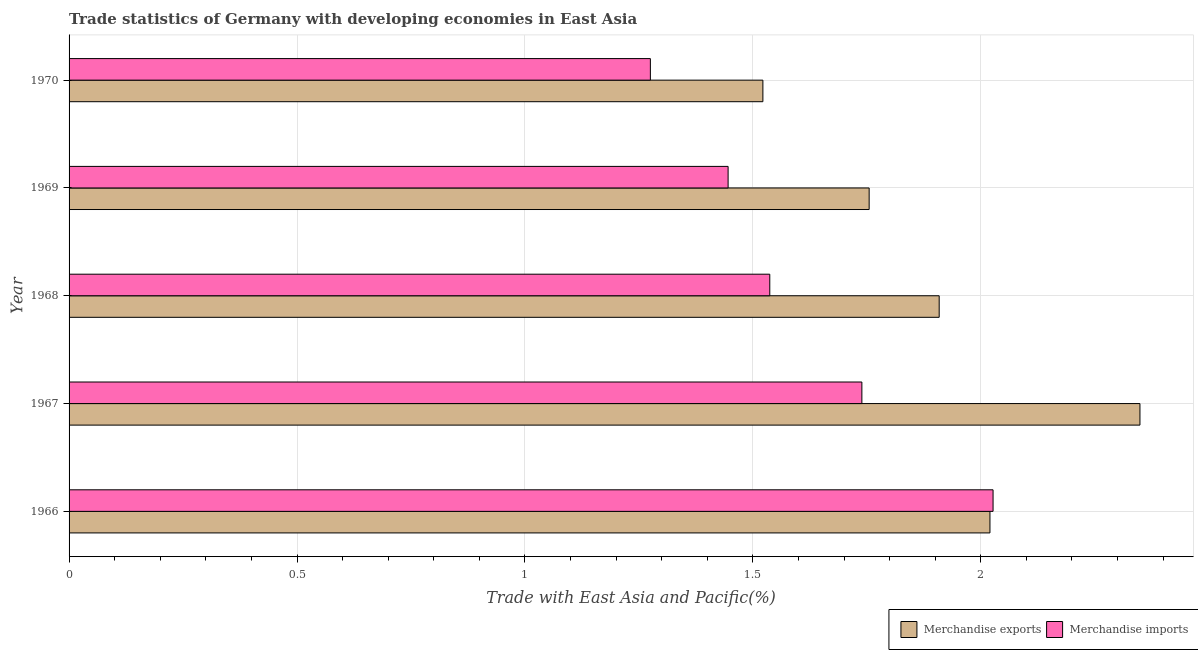How many groups of bars are there?
Make the answer very short. 5. Are the number of bars per tick equal to the number of legend labels?
Provide a succinct answer. Yes. How many bars are there on the 1st tick from the top?
Provide a short and direct response. 2. How many bars are there on the 5th tick from the bottom?
Ensure brevity in your answer.  2. What is the label of the 2nd group of bars from the top?
Keep it short and to the point. 1969. What is the merchandise exports in 1970?
Make the answer very short. 1.52. Across all years, what is the maximum merchandise imports?
Give a very brief answer. 2.03. Across all years, what is the minimum merchandise exports?
Make the answer very short. 1.52. In which year was the merchandise exports maximum?
Your answer should be very brief. 1967. What is the total merchandise exports in the graph?
Provide a short and direct response. 9.56. What is the difference between the merchandise imports in 1966 and that in 1969?
Make the answer very short. 0.58. What is the difference between the merchandise imports in 1967 and the merchandise exports in 1970?
Provide a short and direct response. 0.22. What is the average merchandise imports per year?
Keep it short and to the point. 1.6. In the year 1970, what is the difference between the merchandise imports and merchandise exports?
Keep it short and to the point. -0.25. In how many years, is the merchandise imports greater than 1.5 %?
Give a very brief answer. 3. What is the ratio of the merchandise exports in 1969 to that in 1970?
Keep it short and to the point. 1.15. What is the difference between the highest and the second highest merchandise exports?
Keep it short and to the point. 0.33. Is the sum of the merchandise imports in 1966 and 1970 greater than the maximum merchandise exports across all years?
Offer a terse response. Yes. What does the 1st bar from the top in 1968 represents?
Your answer should be compact. Merchandise imports. Are all the bars in the graph horizontal?
Offer a terse response. Yes. What is the difference between two consecutive major ticks on the X-axis?
Offer a terse response. 0.5. Does the graph contain grids?
Your response must be concise. Yes. Where does the legend appear in the graph?
Provide a short and direct response. Bottom right. How many legend labels are there?
Your answer should be very brief. 2. How are the legend labels stacked?
Keep it short and to the point. Horizontal. What is the title of the graph?
Offer a terse response. Trade statistics of Germany with developing economies in East Asia. Does "Current education expenditure" appear as one of the legend labels in the graph?
Offer a very short reply. No. What is the label or title of the X-axis?
Make the answer very short. Trade with East Asia and Pacific(%). What is the label or title of the Y-axis?
Ensure brevity in your answer.  Year. What is the Trade with East Asia and Pacific(%) in Merchandise exports in 1966?
Offer a terse response. 2.02. What is the Trade with East Asia and Pacific(%) in Merchandise imports in 1966?
Make the answer very short. 2.03. What is the Trade with East Asia and Pacific(%) of Merchandise exports in 1967?
Make the answer very short. 2.35. What is the Trade with East Asia and Pacific(%) in Merchandise imports in 1967?
Your response must be concise. 1.74. What is the Trade with East Asia and Pacific(%) in Merchandise exports in 1968?
Ensure brevity in your answer.  1.91. What is the Trade with East Asia and Pacific(%) in Merchandise imports in 1968?
Offer a terse response. 1.54. What is the Trade with East Asia and Pacific(%) in Merchandise exports in 1969?
Give a very brief answer. 1.76. What is the Trade with East Asia and Pacific(%) in Merchandise imports in 1969?
Ensure brevity in your answer.  1.45. What is the Trade with East Asia and Pacific(%) in Merchandise exports in 1970?
Ensure brevity in your answer.  1.52. What is the Trade with East Asia and Pacific(%) of Merchandise imports in 1970?
Make the answer very short. 1.28. Across all years, what is the maximum Trade with East Asia and Pacific(%) in Merchandise exports?
Offer a very short reply. 2.35. Across all years, what is the maximum Trade with East Asia and Pacific(%) in Merchandise imports?
Your answer should be very brief. 2.03. Across all years, what is the minimum Trade with East Asia and Pacific(%) of Merchandise exports?
Provide a short and direct response. 1.52. Across all years, what is the minimum Trade with East Asia and Pacific(%) in Merchandise imports?
Offer a terse response. 1.28. What is the total Trade with East Asia and Pacific(%) of Merchandise exports in the graph?
Ensure brevity in your answer.  9.56. What is the total Trade with East Asia and Pacific(%) in Merchandise imports in the graph?
Keep it short and to the point. 8.02. What is the difference between the Trade with East Asia and Pacific(%) of Merchandise exports in 1966 and that in 1967?
Ensure brevity in your answer.  -0.33. What is the difference between the Trade with East Asia and Pacific(%) in Merchandise imports in 1966 and that in 1967?
Your answer should be compact. 0.29. What is the difference between the Trade with East Asia and Pacific(%) in Merchandise exports in 1966 and that in 1968?
Give a very brief answer. 0.11. What is the difference between the Trade with East Asia and Pacific(%) of Merchandise imports in 1966 and that in 1968?
Offer a very short reply. 0.49. What is the difference between the Trade with East Asia and Pacific(%) of Merchandise exports in 1966 and that in 1969?
Offer a very short reply. 0.27. What is the difference between the Trade with East Asia and Pacific(%) of Merchandise imports in 1966 and that in 1969?
Your answer should be compact. 0.58. What is the difference between the Trade with East Asia and Pacific(%) of Merchandise exports in 1966 and that in 1970?
Keep it short and to the point. 0.5. What is the difference between the Trade with East Asia and Pacific(%) in Merchandise imports in 1966 and that in 1970?
Your answer should be very brief. 0.75. What is the difference between the Trade with East Asia and Pacific(%) of Merchandise exports in 1967 and that in 1968?
Ensure brevity in your answer.  0.44. What is the difference between the Trade with East Asia and Pacific(%) in Merchandise imports in 1967 and that in 1968?
Offer a very short reply. 0.2. What is the difference between the Trade with East Asia and Pacific(%) of Merchandise exports in 1967 and that in 1969?
Offer a very short reply. 0.59. What is the difference between the Trade with East Asia and Pacific(%) in Merchandise imports in 1967 and that in 1969?
Offer a terse response. 0.29. What is the difference between the Trade with East Asia and Pacific(%) in Merchandise exports in 1967 and that in 1970?
Your answer should be compact. 0.83. What is the difference between the Trade with East Asia and Pacific(%) of Merchandise imports in 1967 and that in 1970?
Your answer should be very brief. 0.46. What is the difference between the Trade with East Asia and Pacific(%) in Merchandise exports in 1968 and that in 1969?
Make the answer very short. 0.15. What is the difference between the Trade with East Asia and Pacific(%) in Merchandise imports in 1968 and that in 1969?
Provide a short and direct response. 0.09. What is the difference between the Trade with East Asia and Pacific(%) of Merchandise exports in 1968 and that in 1970?
Your answer should be compact. 0.39. What is the difference between the Trade with East Asia and Pacific(%) of Merchandise imports in 1968 and that in 1970?
Provide a succinct answer. 0.26. What is the difference between the Trade with East Asia and Pacific(%) in Merchandise exports in 1969 and that in 1970?
Your answer should be very brief. 0.23. What is the difference between the Trade with East Asia and Pacific(%) in Merchandise imports in 1969 and that in 1970?
Your answer should be very brief. 0.17. What is the difference between the Trade with East Asia and Pacific(%) of Merchandise exports in 1966 and the Trade with East Asia and Pacific(%) of Merchandise imports in 1967?
Your answer should be compact. 0.28. What is the difference between the Trade with East Asia and Pacific(%) in Merchandise exports in 1966 and the Trade with East Asia and Pacific(%) in Merchandise imports in 1968?
Keep it short and to the point. 0.48. What is the difference between the Trade with East Asia and Pacific(%) in Merchandise exports in 1966 and the Trade with East Asia and Pacific(%) in Merchandise imports in 1969?
Provide a short and direct response. 0.57. What is the difference between the Trade with East Asia and Pacific(%) of Merchandise exports in 1966 and the Trade with East Asia and Pacific(%) of Merchandise imports in 1970?
Provide a succinct answer. 0.74. What is the difference between the Trade with East Asia and Pacific(%) in Merchandise exports in 1967 and the Trade with East Asia and Pacific(%) in Merchandise imports in 1968?
Your answer should be very brief. 0.81. What is the difference between the Trade with East Asia and Pacific(%) of Merchandise exports in 1967 and the Trade with East Asia and Pacific(%) of Merchandise imports in 1969?
Offer a very short reply. 0.9. What is the difference between the Trade with East Asia and Pacific(%) of Merchandise exports in 1967 and the Trade with East Asia and Pacific(%) of Merchandise imports in 1970?
Keep it short and to the point. 1.07. What is the difference between the Trade with East Asia and Pacific(%) of Merchandise exports in 1968 and the Trade with East Asia and Pacific(%) of Merchandise imports in 1969?
Offer a very short reply. 0.46. What is the difference between the Trade with East Asia and Pacific(%) of Merchandise exports in 1968 and the Trade with East Asia and Pacific(%) of Merchandise imports in 1970?
Offer a terse response. 0.63. What is the difference between the Trade with East Asia and Pacific(%) in Merchandise exports in 1969 and the Trade with East Asia and Pacific(%) in Merchandise imports in 1970?
Keep it short and to the point. 0.48. What is the average Trade with East Asia and Pacific(%) of Merchandise exports per year?
Give a very brief answer. 1.91. What is the average Trade with East Asia and Pacific(%) in Merchandise imports per year?
Give a very brief answer. 1.6. In the year 1966, what is the difference between the Trade with East Asia and Pacific(%) of Merchandise exports and Trade with East Asia and Pacific(%) of Merchandise imports?
Provide a succinct answer. -0.01. In the year 1967, what is the difference between the Trade with East Asia and Pacific(%) of Merchandise exports and Trade with East Asia and Pacific(%) of Merchandise imports?
Ensure brevity in your answer.  0.61. In the year 1968, what is the difference between the Trade with East Asia and Pacific(%) of Merchandise exports and Trade with East Asia and Pacific(%) of Merchandise imports?
Keep it short and to the point. 0.37. In the year 1969, what is the difference between the Trade with East Asia and Pacific(%) of Merchandise exports and Trade with East Asia and Pacific(%) of Merchandise imports?
Your answer should be compact. 0.31. In the year 1970, what is the difference between the Trade with East Asia and Pacific(%) of Merchandise exports and Trade with East Asia and Pacific(%) of Merchandise imports?
Provide a short and direct response. 0.25. What is the ratio of the Trade with East Asia and Pacific(%) of Merchandise exports in 1966 to that in 1967?
Provide a short and direct response. 0.86. What is the ratio of the Trade with East Asia and Pacific(%) of Merchandise imports in 1966 to that in 1967?
Your answer should be very brief. 1.17. What is the ratio of the Trade with East Asia and Pacific(%) of Merchandise exports in 1966 to that in 1968?
Your answer should be very brief. 1.06. What is the ratio of the Trade with East Asia and Pacific(%) in Merchandise imports in 1966 to that in 1968?
Make the answer very short. 1.32. What is the ratio of the Trade with East Asia and Pacific(%) in Merchandise exports in 1966 to that in 1969?
Your answer should be very brief. 1.15. What is the ratio of the Trade with East Asia and Pacific(%) in Merchandise imports in 1966 to that in 1969?
Offer a very short reply. 1.4. What is the ratio of the Trade with East Asia and Pacific(%) in Merchandise exports in 1966 to that in 1970?
Offer a terse response. 1.33. What is the ratio of the Trade with East Asia and Pacific(%) of Merchandise imports in 1966 to that in 1970?
Your response must be concise. 1.59. What is the ratio of the Trade with East Asia and Pacific(%) of Merchandise exports in 1967 to that in 1968?
Keep it short and to the point. 1.23. What is the ratio of the Trade with East Asia and Pacific(%) in Merchandise imports in 1967 to that in 1968?
Your answer should be very brief. 1.13. What is the ratio of the Trade with East Asia and Pacific(%) in Merchandise exports in 1967 to that in 1969?
Ensure brevity in your answer.  1.34. What is the ratio of the Trade with East Asia and Pacific(%) of Merchandise imports in 1967 to that in 1969?
Your answer should be very brief. 1.2. What is the ratio of the Trade with East Asia and Pacific(%) of Merchandise exports in 1967 to that in 1970?
Keep it short and to the point. 1.54. What is the ratio of the Trade with East Asia and Pacific(%) of Merchandise imports in 1967 to that in 1970?
Provide a succinct answer. 1.36. What is the ratio of the Trade with East Asia and Pacific(%) of Merchandise exports in 1968 to that in 1969?
Your answer should be very brief. 1.09. What is the ratio of the Trade with East Asia and Pacific(%) in Merchandise imports in 1968 to that in 1969?
Offer a terse response. 1.06. What is the ratio of the Trade with East Asia and Pacific(%) of Merchandise exports in 1968 to that in 1970?
Give a very brief answer. 1.25. What is the ratio of the Trade with East Asia and Pacific(%) in Merchandise imports in 1968 to that in 1970?
Your answer should be compact. 1.21. What is the ratio of the Trade with East Asia and Pacific(%) of Merchandise exports in 1969 to that in 1970?
Provide a short and direct response. 1.15. What is the ratio of the Trade with East Asia and Pacific(%) in Merchandise imports in 1969 to that in 1970?
Keep it short and to the point. 1.13. What is the difference between the highest and the second highest Trade with East Asia and Pacific(%) in Merchandise exports?
Keep it short and to the point. 0.33. What is the difference between the highest and the second highest Trade with East Asia and Pacific(%) of Merchandise imports?
Provide a short and direct response. 0.29. What is the difference between the highest and the lowest Trade with East Asia and Pacific(%) of Merchandise exports?
Offer a very short reply. 0.83. What is the difference between the highest and the lowest Trade with East Asia and Pacific(%) of Merchandise imports?
Offer a terse response. 0.75. 